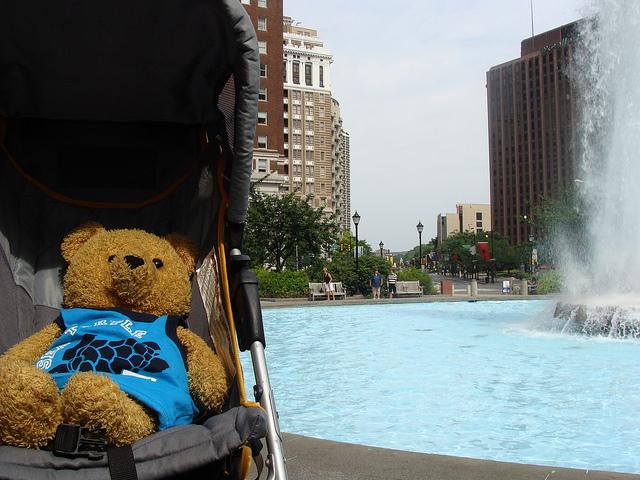What is the bear doing?
Give a very brief answer. Sitting. What color is the water?
Write a very short answer. Blue. What is this on the background?
Give a very brief answer. Fountain. 